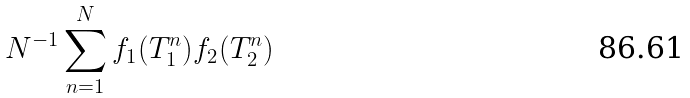<formula> <loc_0><loc_0><loc_500><loc_500>N ^ { - 1 } \sum _ { n = 1 } ^ { N } f _ { 1 } ( T _ { 1 } ^ { n } ) f _ { 2 } ( T _ { 2 } ^ { n } )</formula> 